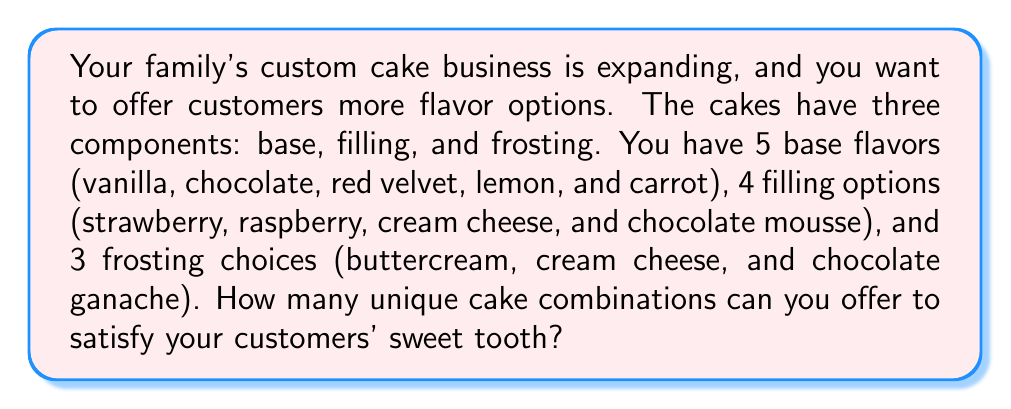Help me with this question. To solve this problem, we'll use the multiplication principle of combinatorics. This principle states that if we have $m$ ways of doing something and $n$ ways of doing another thing, then there are $m \times n$ ways of doing both things.

Let's break down the problem:

1. Base flavors: 5 options
2. Filling options: 4 options
3. Frosting choices: 3 options

To find the total number of unique combinations, we multiply these numbers together:

$$ \text{Total combinations} = \text{Base options} \times \text{Filling options} \times \text{Frosting options} $$

$$ \text{Total combinations} = 5 \times 4 \times 3 $$

$$ \text{Total combinations} = 60 $$

This means that with the given options for base, filling, and frosting, you can offer 60 unique cake combinations to your customers.

To visualize this, we can think of it as a tree diagram where each level represents a component of the cake. The first level has 5 branches (base flavors), each of those branches splits into 4 (filling options), and then each of those splits into 3 (frosting choices). Counting all the possible paths from root to leaf gives us the total number of combinations.
Answer: 60 unique cake combinations 